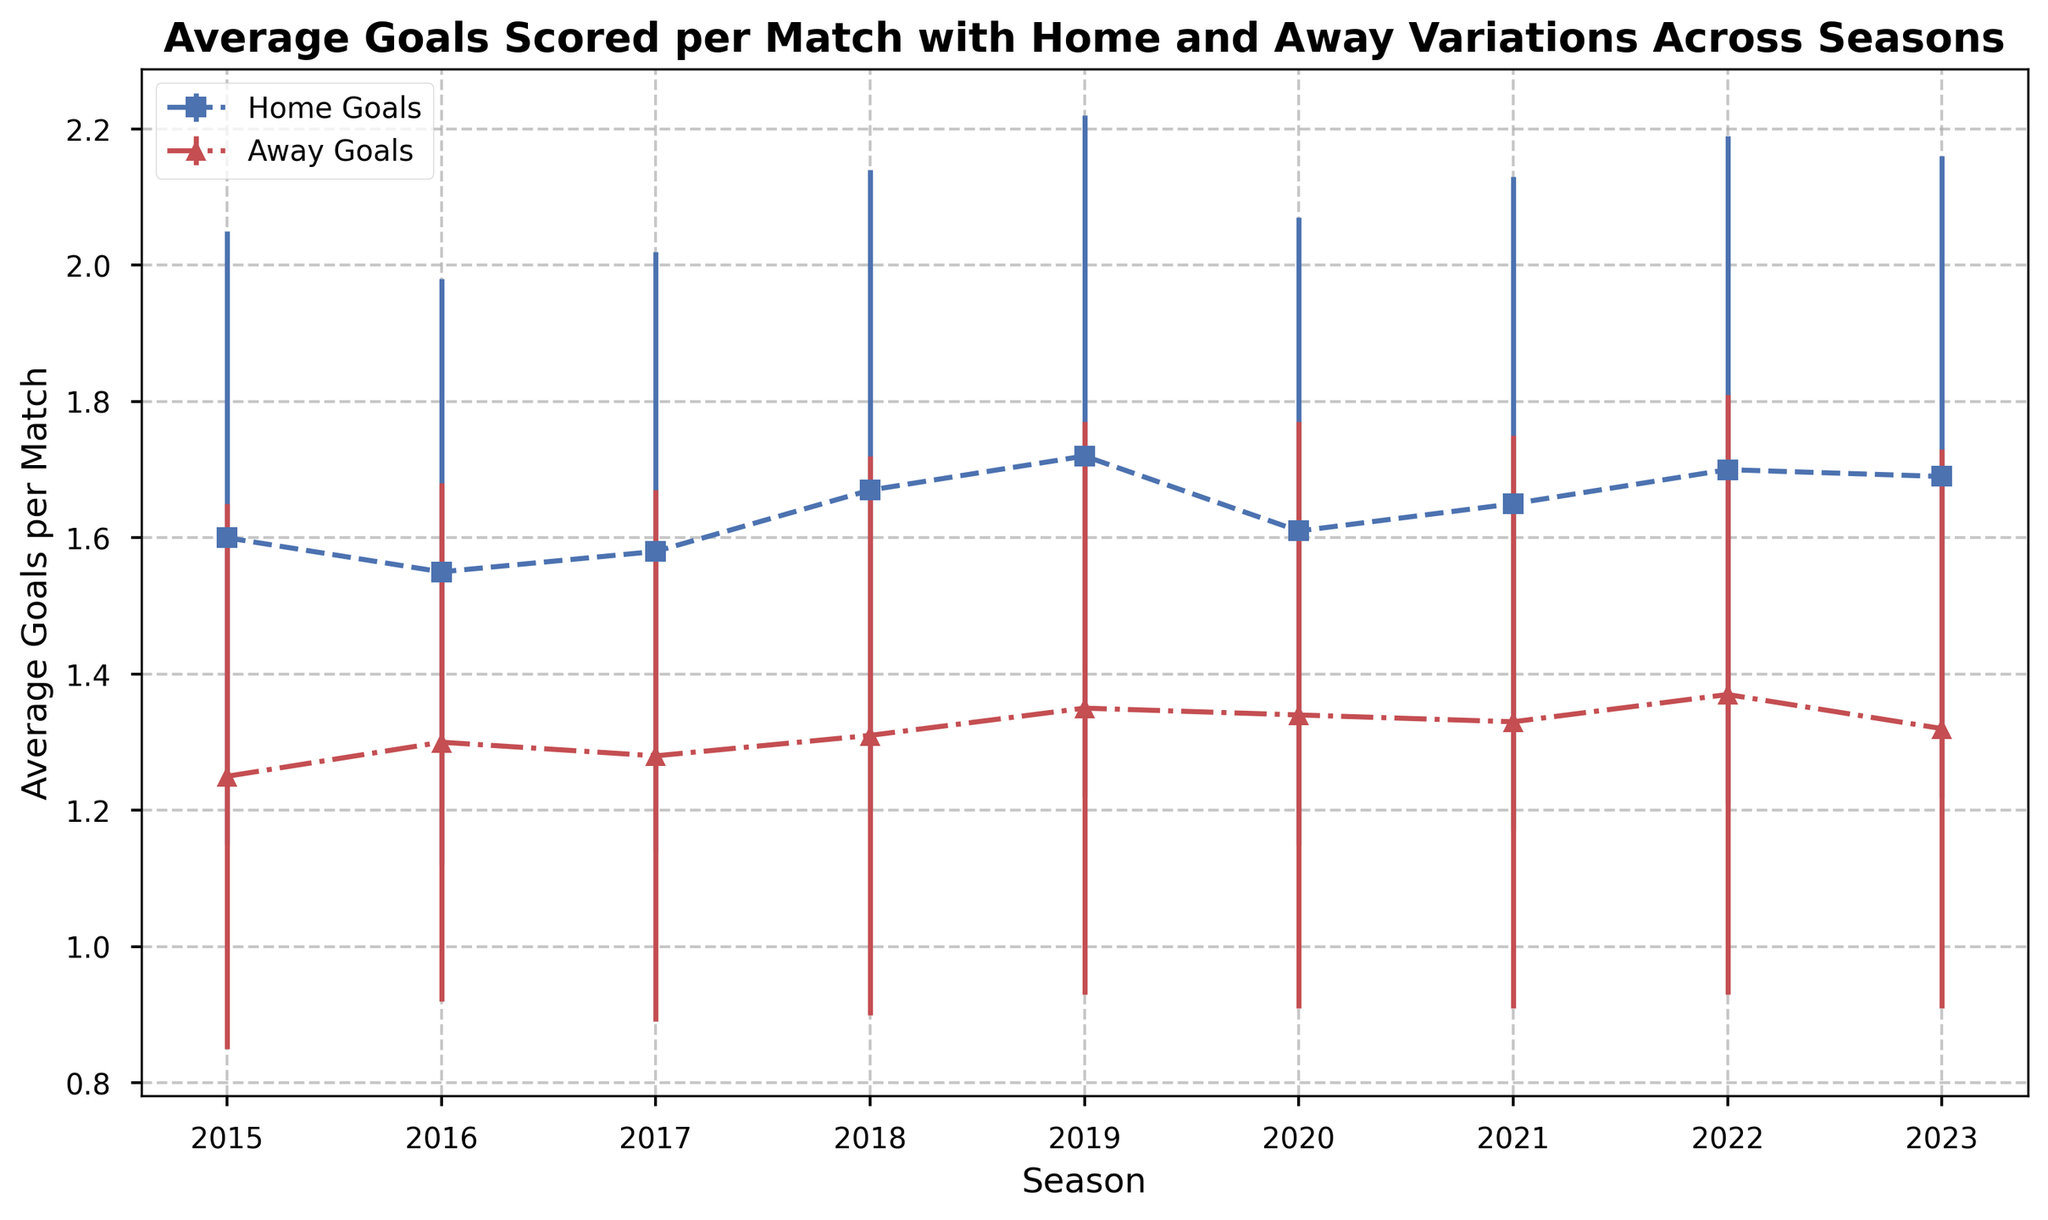What is the season with the highest average home goals per match? From the figure, we can observe that the highest point for home goals is in the 2019 season. This point also matches the numerical data where average home goals for 2019 are 1.72.
Answer: 2019 Between which two consecutive seasons was the largest increase in average home goals per match? By examining the slopes of the home goal lines, the largest positive slope (steepest ascent) occurs between the 2018 and 2019 seasons. This can be confirmed by numerically comparing the differences: 1.72 (2019) - 1.67 (2018) = 0.05, which is the largest increment.
Answer: Between 2018 and 2019 In which season is the difference between average home and away goals the smallest? To determine this, subtract the away goals from the home goals for each season. The smallest difference is found in 2023, where the difference is 1.69 (home) - 1.32 (away) = 0.37.
Answer: 2023 What is the average of the average away goals per match across the 2017 to 2019 seasons? To calculate this, sum the average away goals for these seasons and divide by the number of seasons (3). The calculation is (1.28 (2017) + 1.31 (2018) + 1.35 (2019))/3 = 3.94/3 = 1.313.
Answer: 1.313 Which season shows the smallest standard deviation in both home and away goals? By comparing the standard deviations in the figure, both visually and numerically, the 2016 season has the smallest values: 0.43 for home and 0.38 for away goals.
Answer: 2016 In how many seasons is the average home goal rate greater than the average away goal rate by at least 0.35 goals? To answer this, check the differences for each season and count those that meet the criterion: 2015 (1.60-1.25=0.35), 2019 (1.72-1.35=0.37), 2022 (1.70-1.37=0.33), and 2023 (1.69-1.32=0.37). Only 2015 and 2019 meet the criteria.
Answer: 2 Which season had a higher average goal rate for away matches compared to the previous season? Inspecting the figure, away goals increased in 2016 (1.30 from 1.25 in 2015), 2018 (1.31 from 1.28 in 2017), 2019 (1.35 from 1.31 in 2018), 2020 (1.34 from 1.35 in 2019), 2021 (1.33 from 1.34 in 2020), and 2022 (1.37 from 1.33 in 2021). The 2016 season is the first instance.
Answer: 2016 Is there any season where the average away goals per match are exactly the same as the previous season? By looking closely at the plotted points and comparing values, no two consecutive years have the same average away goals per match.
Answer: No 